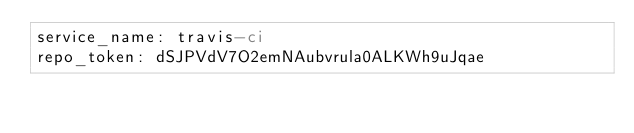<code> <loc_0><loc_0><loc_500><loc_500><_YAML_>service_name: travis-ci
repo_token: dSJPVdV7O2emNAubvrula0ALKWh9uJqae
</code> 